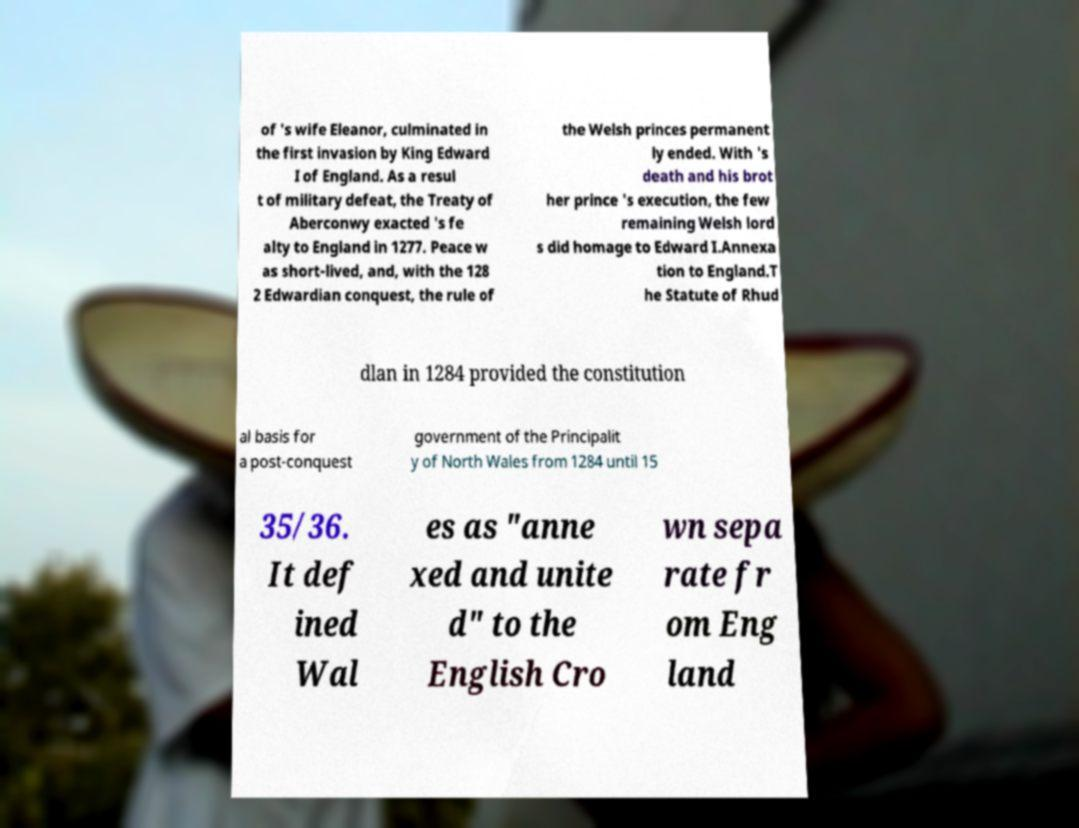I need the written content from this picture converted into text. Can you do that? of 's wife Eleanor, culminated in the first invasion by King Edward I of England. As a resul t of military defeat, the Treaty of Aberconwy exacted 's fe alty to England in 1277. Peace w as short-lived, and, with the 128 2 Edwardian conquest, the rule of the Welsh princes permanent ly ended. With 's death and his brot her prince 's execution, the few remaining Welsh lord s did homage to Edward I.Annexa tion to England.T he Statute of Rhud dlan in 1284 provided the constitution al basis for a post-conquest government of the Principalit y of North Wales from 1284 until 15 35/36. It def ined Wal es as "anne xed and unite d" to the English Cro wn sepa rate fr om Eng land 